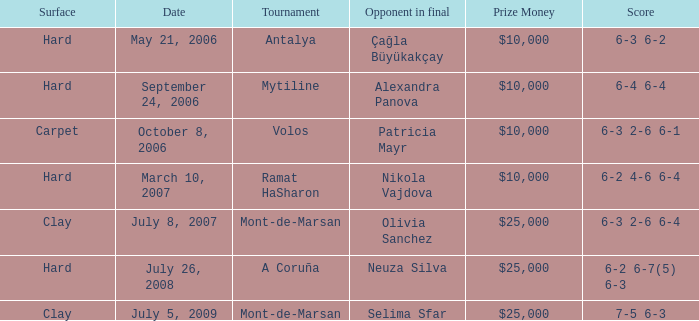Who was the opponent on carpet in a final? Patricia Mayr. 